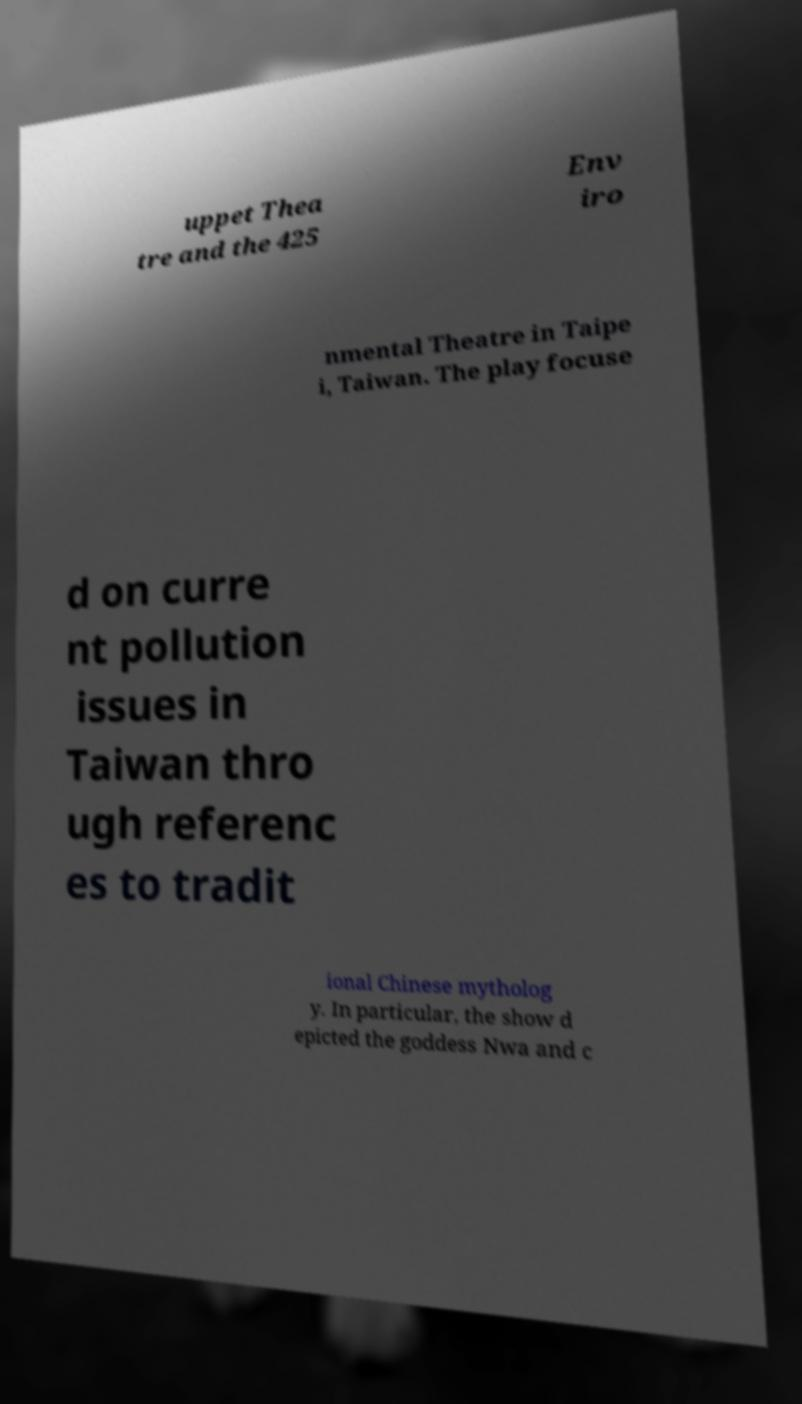Please read and relay the text visible in this image. What does it say? uppet Thea tre and the 425 Env iro nmental Theatre in Taipe i, Taiwan. The play focuse d on curre nt pollution issues in Taiwan thro ugh referenc es to tradit ional Chinese mytholog y. In particular, the show d epicted the goddess Nwa and c 